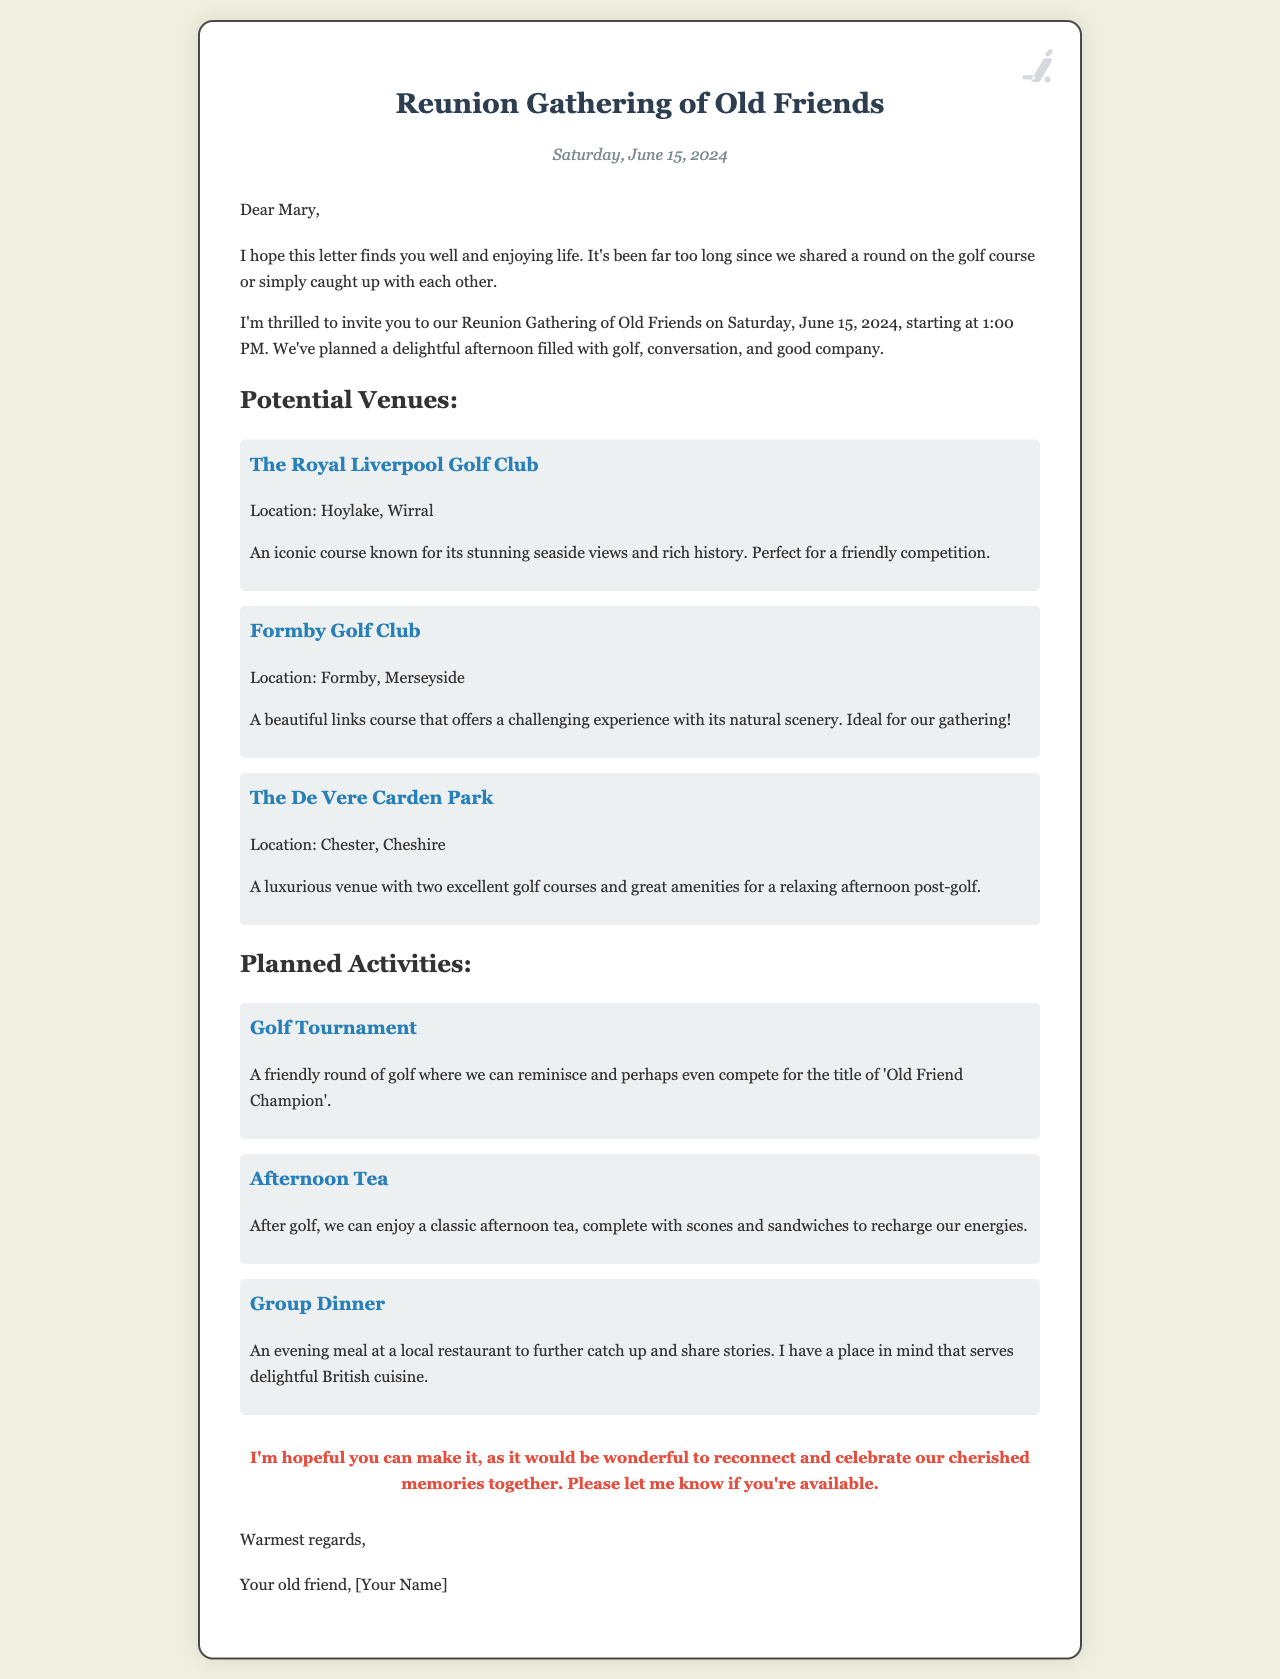What date is the reunion gathering? The date of the reunion gathering is clearly stated in the letter as Saturday, June 15, 2024.
Answer: Saturday, June 15, 2024 What time does the gathering start? The starting time for the gathering is mentioned in the letter as 1:00 PM.
Answer: 1:00 PM What is one of the proposed venues for golf? The letter lists multiple venues, one of which is The Royal Liverpool Golf Club.
Answer: The Royal Liverpool Golf Club What activity follows the golf tournament? The letter specifies that afternoon tea is planned after the golf tournament.
Answer: Afternoon Tea How many venues are mentioned in total? The letter describes three potential venues for the gathering.
Answer: Three What is the anticipated title for the golf tournament winner? The letter humorously refers to the tournament winner as the 'Old Friend Champion'.
Answer: Old Friend Champion Who is the letter addressed to? The greeting in the letter indicates it is addressed to Mary.
Answer: Mary What type of cuisine is mentioned for the group dinner? The letter notes that the place in mind for dinner serves delightful British cuisine.
Answer: British cuisine 